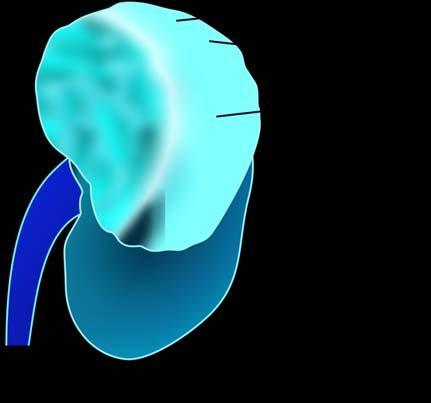what does rest of the kidney have?
Answer the question using a single word or phrase. Reniform contour 